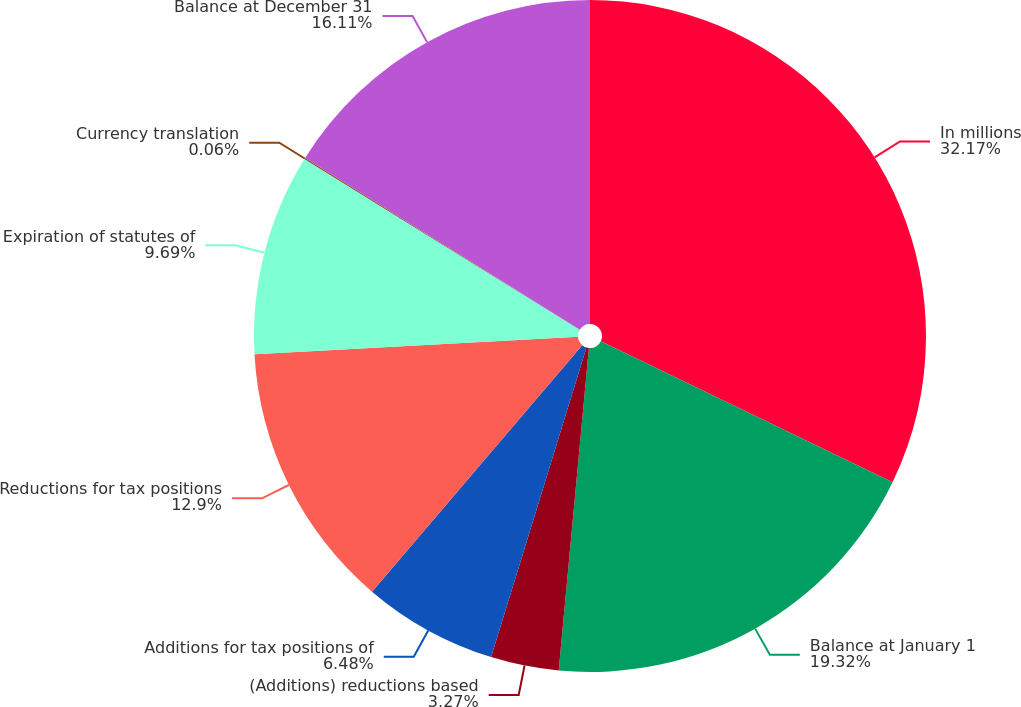<chart> <loc_0><loc_0><loc_500><loc_500><pie_chart><fcel>In millions<fcel>Balance at January 1<fcel>(Additions) reductions based<fcel>Additions for tax positions of<fcel>Reductions for tax positions<fcel>Expiration of statutes of<fcel>Currency translation<fcel>Balance at December 31<nl><fcel>32.16%<fcel>19.32%<fcel>3.27%<fcel>6.48%<fcel>12.9%<fcel>9.69%<fcel>0.06%<fcel>16.11%<nl></chart> 